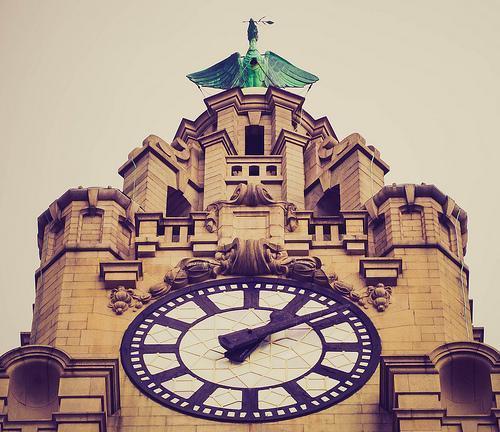How many clocks are shown?
Give a very brief answer. 1. How many figurines can be seen?
Give a very brief answer. 1. 